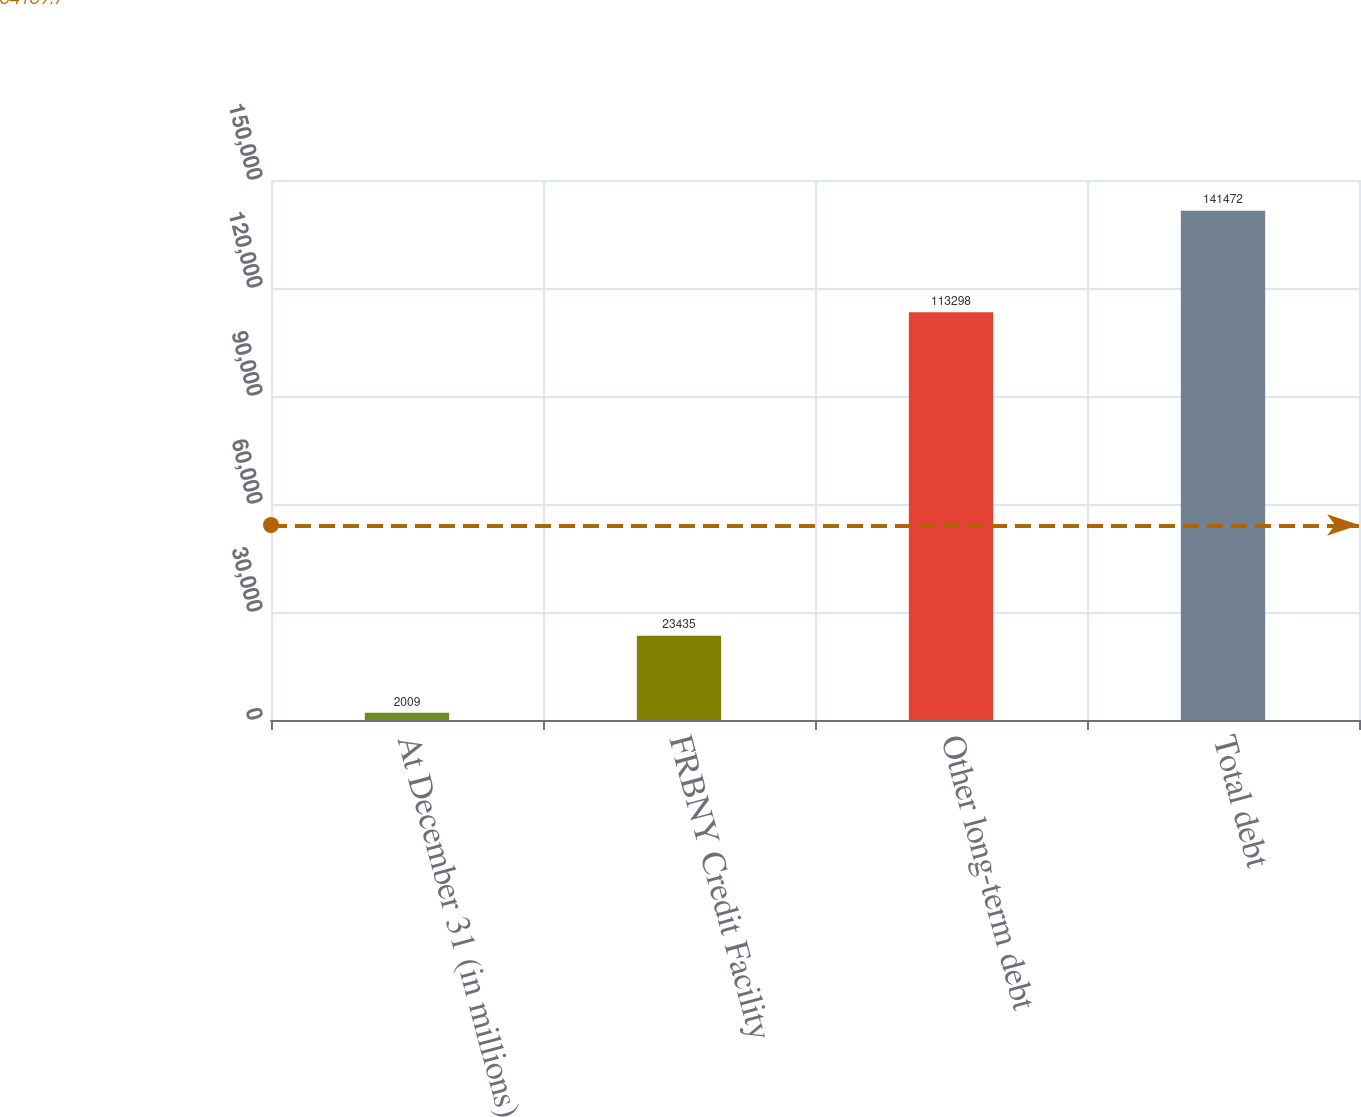<chart> <loc_0><loc_0><loc_500><loc_500><bar_chart><fcel>At December 31 (in millions)<fcel>FRBNY Credit Facility<fcel>Other long-term debt<fcel>Total debt<nl><fcel>2009<fcel>23435<fcel>113298<fcel>141472<nl></chart> 